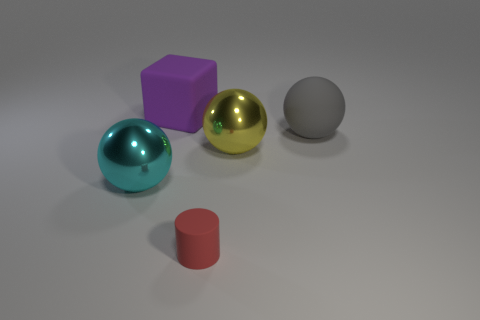What material do the objects appear to be made of, and how can you tell? The objects in the image have a look that suggests they are made of a metallic or shiny plastic material. This is evident from the way they reflect light and show highlights and shadows on their surfaces, typical characteristics of glossy and reflective materials. 